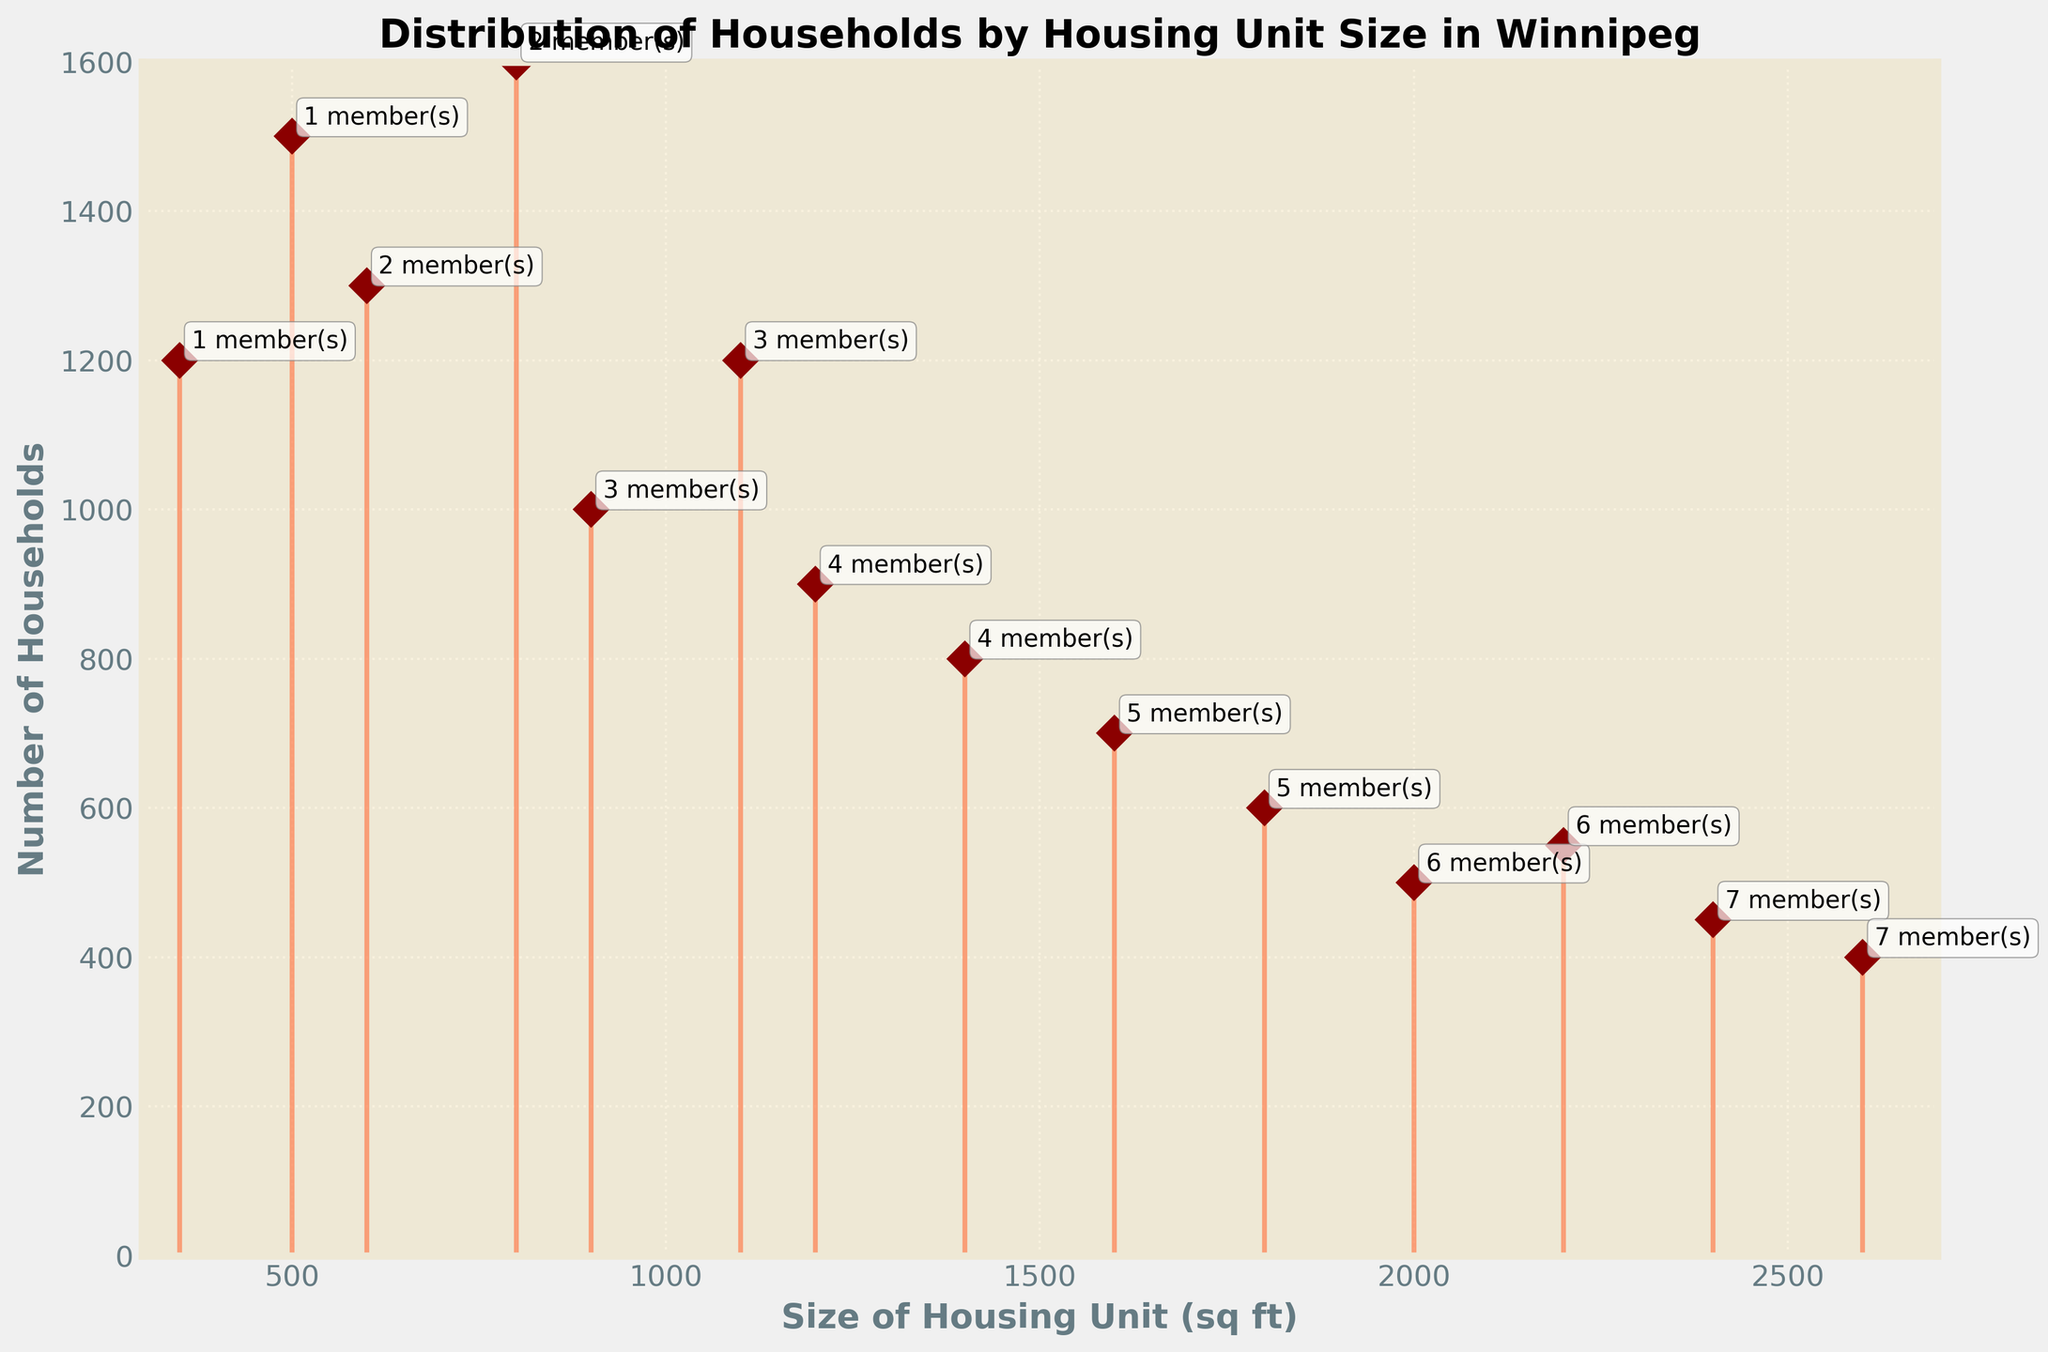What is the title of the plot? The title is clearly visible at the top of the plot, serving as a description of the data being displayed.
Answer: Distribution of Households by Housing Unit Size in Winnipeg What range of sizes for housing units is displayed on the x-axis? The x-axis has labels that indicate the range of sizes for housing units, from the minimum to the maximum value.
Answer: 300 to 2700 sq ft How many households live in 1600 square feet housing units? The data point corresponding to 1600 sq ft on the x-axis has a stem line reaching up to a particular value on the y-axis, indicating the number of households.
Answer: 700 Which housing unit size has the highest number of households? One of the data points on the plot will have the highest stem line, making it clear which size has the most households.
Answer: 500 sq ft How many members are indicated for 1400 square feet housing units? Next to the data point for 1400 sq ft, there is an annotation with the number of members, making this information straightforward to find.
Answer: 4 members What is the total number of households living in housing units between 1200 and 1800 square feet? You need to sum up the number of households for the data points where the housing unit size is between 1200 and 1800 sq ft: 900 (1200 sq ft) + 800 (1400 sq ft) + 700 (1600 sq ft) + 600 (1800 sq ft).
Answer: 3000 Which housing unit sizes have fewer than 500 households? Observe the data points where the y-axis value, the number of households, is less than 500, then note the corresponding x-axis values (housing unit sizes).
Answer: 2000, 2200, 2400, 2600 sq ft How does the number of households change as the size of the housing unit increases from 350 to 2600 square feet? This requires observing the trend in the stem lines from the leftmost point (350 sq ft) to the rightmost point (2600 sq ft) and noting the overall change in the height of the lines as the housing unit size increases.
Answer: Decreases For housing units of 600 and 1100 square feet, how many more households live in the smaller unit? Compare the height of the stem lines for 600 sq ft and 1100 sq ft to find the number of households in each, then subtract to find the difference.
Answer: 100 more households live in 600 sq ft 